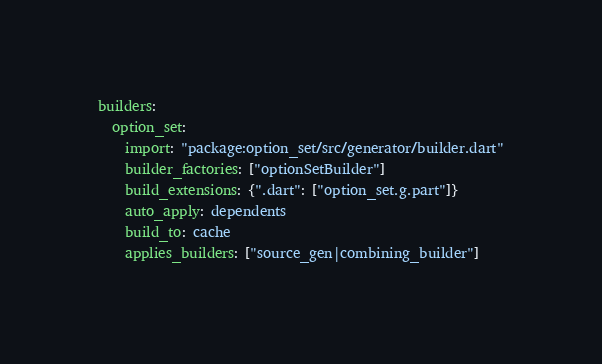Convert code to text. <code><loc_0><loc_0><loc_500><loc_500><_YAML_>builders:
  option_set:
    import: "package:option_set/src/generator/builder.dart"
    builder_factories: ["optionSetBuilder"]
    build_extensions: {".dart": ["option_set.g.part"]}
    auto_apply: dependents
    build_to: cache
    applies_builders: ["source_gen|combining_builder"]</code> 